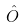<formula> <loc_0><loc_0><loc_500><loc_500>\hat { O }</formula> 